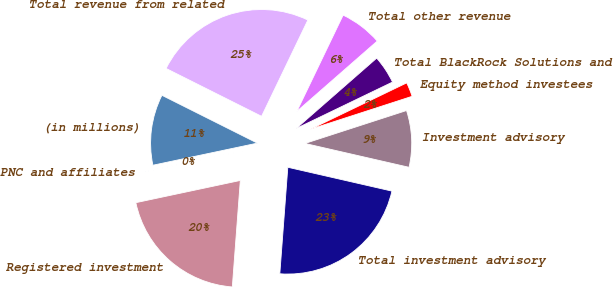<chart> <loc_0><loc_0><loc_500><loc_500><pie_chart><fcel>(in millions)<fcel>PNC and affiliates<fcel>Registered investment<fcel>Total investment advisory<fcel>Investment advisory<fcel>Equity method investees<fcel>Total BlackRock Solutions and<fcel>Total other revenue<fcel>Total revenue from related<nl><fcel>10.71%<fcel>0.02%<fcel>20.47%<fcel>22.61%<fcel>8.57%<fcel>2.16%<fcel>4.29%<fcel>6.43%<fcel>24.74%<nl></chart> 